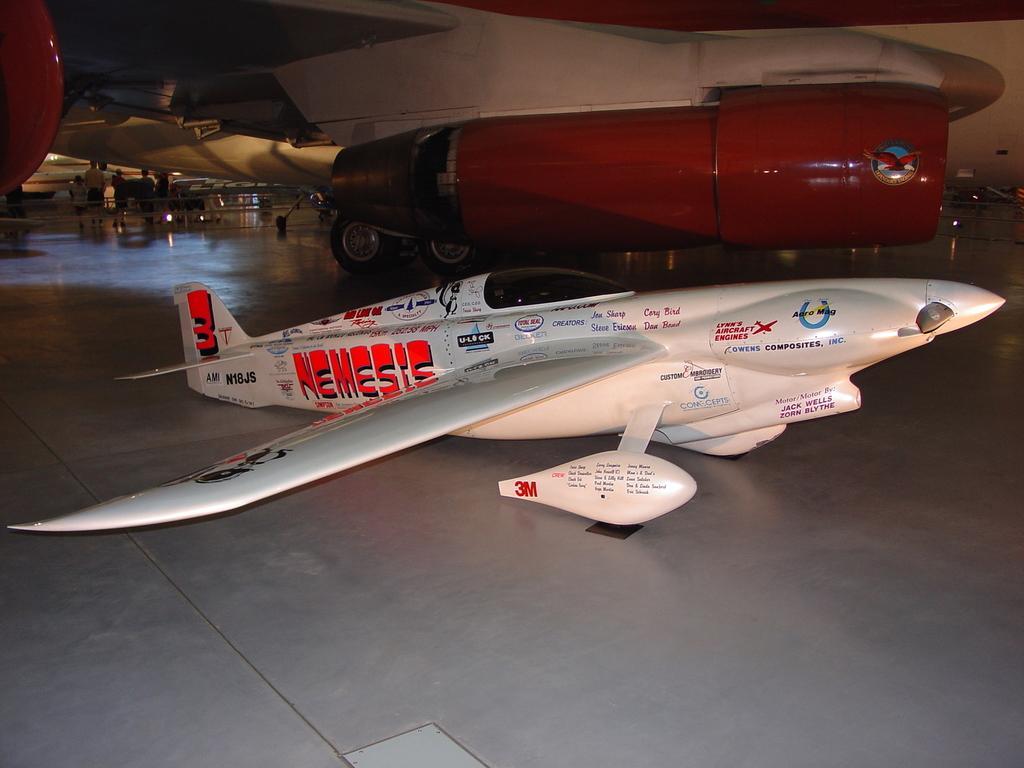Can you describe this image briefly? In this image we can see an aircraft, there is an airplane and in the background of the image there are some persons standing inside the hangar. 